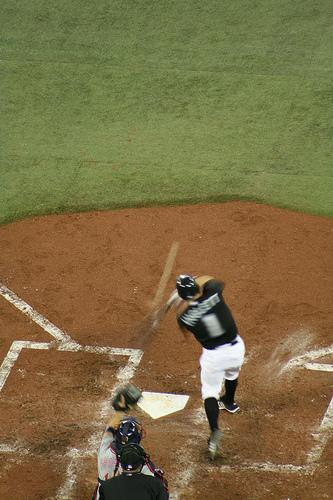How would you assess the quality of this image based on the provided information? Is it clear and well-defined, or does it lack details? The image quality seems to be clear and well-defined based on the detailed object descriptions, positions, and sizes. From the image, can you infer any sentiment or emotions that may be experienced by the subjects or viewers? The image captures an intense baseball game moment, which could evoke excitement and anticipation in viewers and the subjects within the scene. Describe the catcher's appearance based on the image details. The catcher is wearing a baseball uniform, head protection, and has a glove up to catch the ball. Count the number of players and officials wearing protective helmets in the image. Three individuals are wearing protective helmets - the batter, the catcher, and the umpire. Analyze the interaction between the batter, the bat, and the ball in the image. The batter is swinging the bat in a hitting motion, and it appears that the bat is on the path to make contact with the ball, as suggested by the phrase "the bat is in motion." Identify the position of the white lines on the field in relation to the players. The white lines on the field are near home plate and home mound, surrounding the area where the players and umpire are standing. Please describe the scene captured in the image focusing primarily on the interaction between the players, umpire, and their equipment. In the image, a batter is swinging the bat to hit the ball, while the catcher is attempting to catch it wearing a glove and head protection. The umpire stands behind the catcher, also wearing head protection, observing the game closely. What is the prominent action performed by the baseball player in this image? The baseball player is swinging the bat in a hitting motion. Based on the information provided, can you infer how the batter's uniform looks like? The batter is wearing a black and white uniform, with a black helmet and a black shirt that has the number one and white lettering on it. How many significant objects or subjects are in the scene related to the baseball game? There are at least nine significant objects or subjects, including players, umpire, bat, helmet, glove, home base, uniform, field lines, and footprints. 